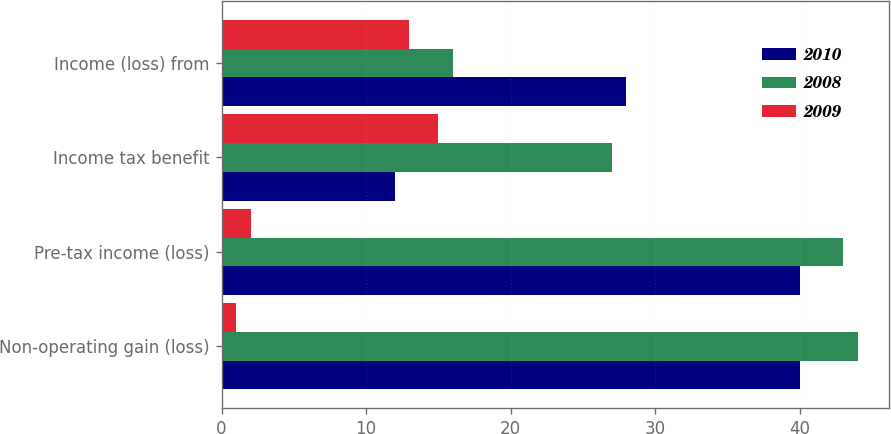<chart> <loc_0><loc_0><loc_500><loc_500><stacked_bar_chart><ecel><fcel>Non-operating gain (loss)<fcel>Pre-tax income (loss)<fcel>Income tax benefit<fcel>Income (loss) from<nl><fcel>2010<fcel>40<fcel>40<fcel>12<fcel>28<nl><fcel>2008<fcel>44<fcel>43<fcel>27<fcel>16<nl><fcel>2009<fcel>1<fcel>2<fcel>15<fcel>13<nl></chart> 